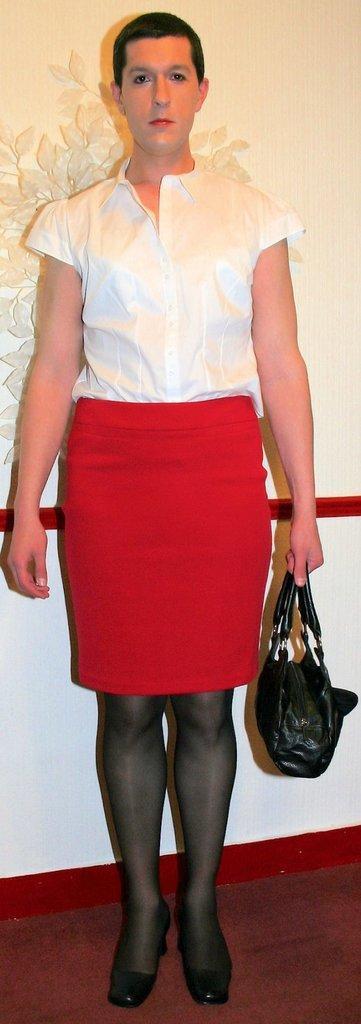Can you describe this image briefly? In this image I can see a person is standing and holding a handbag. 